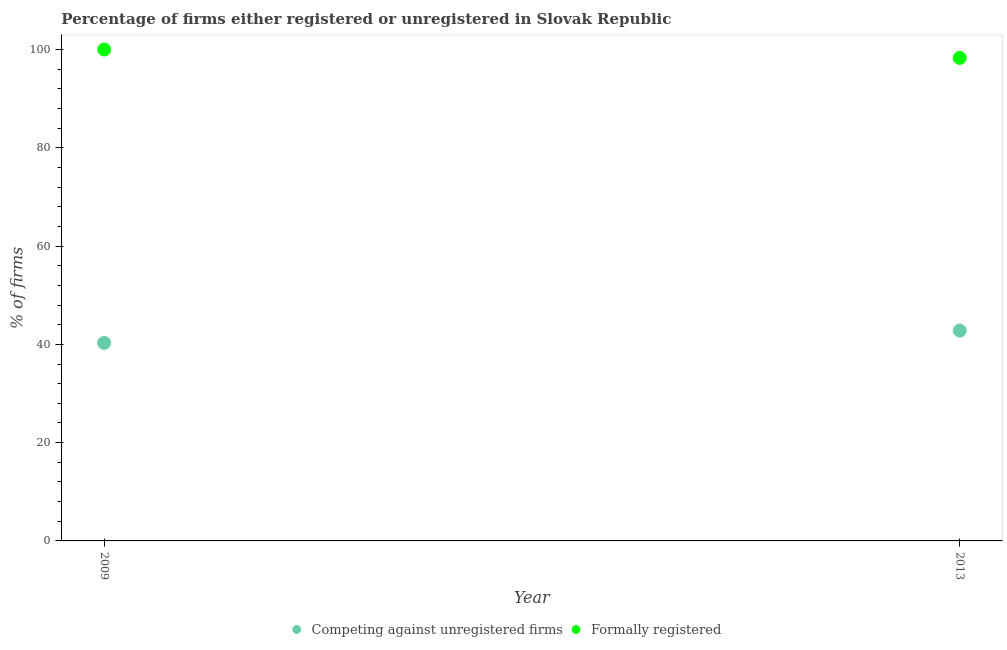What is the percentage of formally registered firms in 2013?
Keep it short and to the point. 98.3. Across all years, what is the maximum percentage of formally registered firms?
Your response must be concise. 100. Across all years, what is the minimum percentage of formally registered firms?
Keep it short and to the point. 98.3. In which year was the percentage of formally registered firms minimum?
Your response must be concise. 2013. What is the total percentage of registered firms in the graph?
Provide a succinct answer. 83.1. What is the difference between the percentage of registered firms in 2013 and the percentage of formally registered firms in 2009?
Offer a very short reply. -57.2. What is the average percentage of registered firms per year?
Keep it short and to the point. 41.55. In the year 2013, what is the difference between the percentage of registered firms and percentage of formally registered firms?
Keep it short and to the point. -55.5. What is the ratio of the percentage of formally registered firms in 2009 to that in 2013?
Ensure brevity in your answer.  1.02. Is the percentage of formally registered firms in 2009 less than that in 2013?
Offer a very short reply. No. Is the percentage of registered firms strictly greater than the percentage of formally registered firms over the years?
Make the answer very short. No. How many dotlines are there?
Make the answer very short. 2. How many years are there in the graph?
Keep it short and to the point. 2. Are the values on the major ticks of Y-axis written in scientific E-notation?
Give a very brief answer. No. Does the graph contain grids?
Provide a succinct answer. No. Where does the legend appear in the graph?
Offer a very short reply. Bottom center. How many legend labels are there?
Offer a very short reply. 2. What is the title of the graph?
Your answer should be very brief. Percentage of firms either registered or unregistered in Slovak Republic. Does "Primary school" appear as one of the legend labels in the graph?
Your answer should be compact. No. What is the label or title of the X-axis?
Provide a short and direct response. Year. What is the label or title of the Y-axis?
Ensure brevity in your answer.  % of firms. What is the % of firms of Competing against unregistered firms in 2009?
Your answer should be compact. 40.3. What is the % of firms of Formally registered in 2009?
Provide a short and direct response. 100. What is the % of firms in Competing against unregistered firms in 2013?
Offer a terse response. 42.8. What is the % of firms of Formally registered in 2013?
Offer a terse response. 98.3. Across all years, what is the maximum % of firms in Competing against unregistered firms?
Provide a succinct answer. 42.8. Across all years, what is the minimum % of firms of Competing against unregistered firms?
Your answer should be compact. 40.3. Across all years, what is the minimum % of firms in Formally registered?
Your answer should be very brief. 98.3. What is the total % of firms of Competing against unregistered firms in the graph?
Your answer should be compact. 83.1. What is the total % of firms in Formally registered in the graph?
Make the answer very short. 198.3. What is the difference between the % of firms of Competing against unregistered firms in 2009 and that in 2013?
Your answer should be compact. -2.5. What is the difference between the % of firms in Formally registered in 2009 and that in 2013?
Offer a very short reply. 1.7. What is the difference between the % of firms of Competing against unregistered firms in 2009 and the % of firms of Formally registered in 2013?
Make the answer very short. -58. What is the average % of firms of Competing against unregistered firms per year?
Your answer should be very brief. 41.55. What is the average % of firms of Formally registered per year?
Your answer should be compact. 99.15. In the year 2009, what is the difference between the % of firms of Competing against unregistered firms and % of firms of Formally registered?
Make the answer very short. -59.7. In the year 2013, what is the difference between the % of firms of Competing against unregistered firms and % of firms of Formally registered?
Give a very brief answer. -55.5. What is the ratio of the % of firms of Competing against unregistered firms in 2009 to that in 2013?
Your answer should be compact. 0.94. What is the ratio of the % of firms in Formally registered in 2009 to that in 2013?
Offer a very short reply. 1.02. What is the difference between the highest and the second highest % of firms in Competing against unregistered firms?
Offer a terse response. 2.5. What is the difference between the highest and the second highest % of firms in Formally registered?
Your response must be concise. 1.7. What is the difference between the highest and the lowest % of firms in Competing against unregistered firms?
Ensure brevity in your answer.  2.5. What is the difference between the highest and the lowest % of firms in Formally registered?
Make the answer very short. 1.7. 